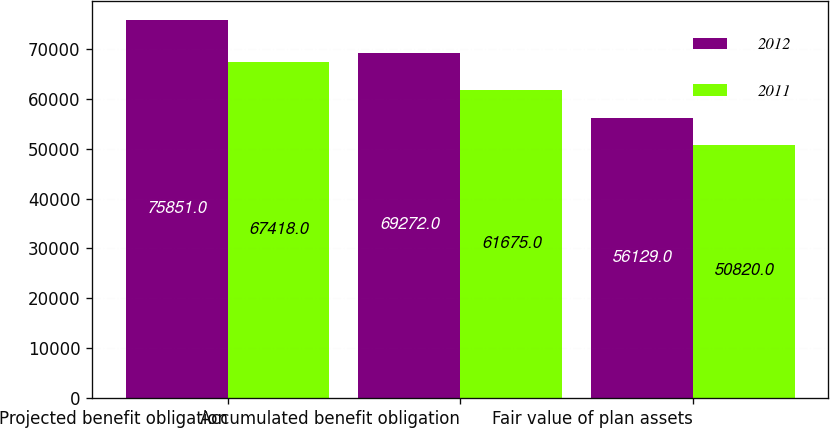Convert chart. <chart><loc_0><loc_0><loc_500><loc_500><stacked_bar_chart><ecel><fcel>Projected benefit obligation<fcel>Accumulated benefit obligation<fcel>Fair value of plan assets<nl><fcel>2012<fcel>75851<fcel>69272<fcel>56129<nl><fcel>2011<fcel>67418<fcel>61675<fcel>50820<nl></chart> 